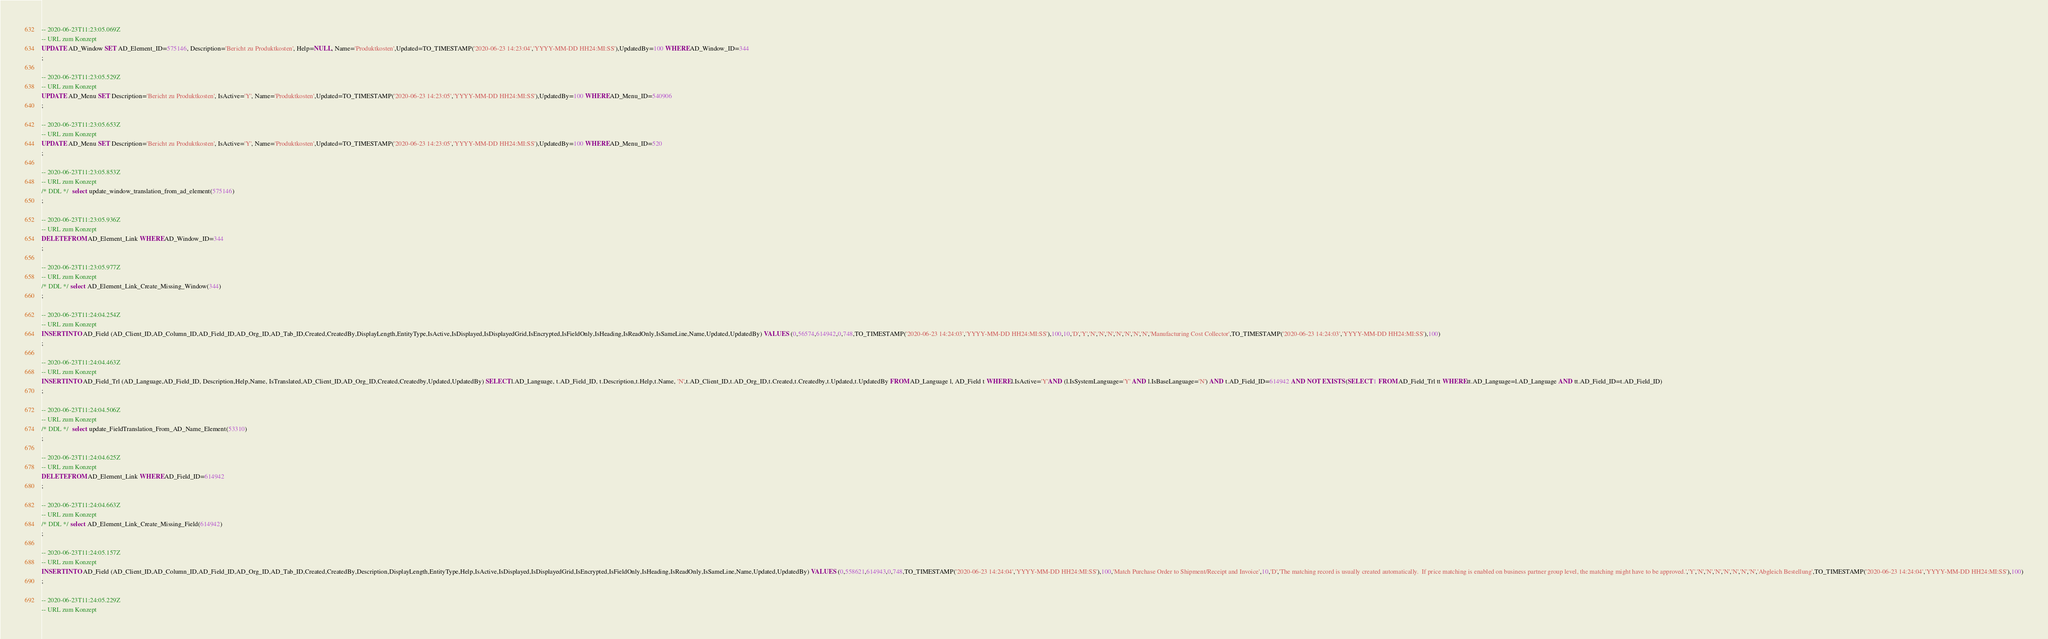Convert code to text. <code><loc_0><loc_0><loc_500><loc_500><_SQL_>-- 2020-06-23T11:23:05.069Z
-- URL zum Konzept
UPDATE AD_Window SET AD_Element_ID=575146, Description='Bericht zu Produktkosten', Help=NULL, Name='Produktkosten',Updated=TO_TIMESTAMP('2020-06-23 14:23:04','YYYY-MM-DD HH24:MI:SS'),UpdatedBy=100 WHERE AD_Window_ID=344
;

-- 2020-06-23T11:23:05.529Z
-- URL zum Konzept
UPDATE AD_Menu SET Description='Bericht zu Produktkosten', IsActive='Y', Name='Produktkosten',Updated=TO_TIMESTAMP('2020-06-23 14:23:05','YYYY-MM-DD HH24:MI:SS'),UpdatedBy=100 WHERE AD_Menu_ID=540906
;

-- 2020-06-23T11:23:05.653Z
-- URL zum Konzept
UPDATE AD_Menu SET Description='Bericht zu Produktkosten', IsActive='Y', Name='Produktkosten',Updated=TO_TIMESTAMP('2020-06-23 14:23:05','YYYY-MM-DD HH24:MI:SS'),UpdatedBy=100 WHERE AD_Menu_ID=520
;

-- 2020-06-23T11:23:05.853Z
-- URL zum Konzept
/* DDL */  select update_window_translation_from_ad_element(575146) 
;

-- 2020-06-23T11:23:05.936Z
-- URL zum Konzept
DELETE FROM AD_Element_Link WHERE AD_Window_ID=344
;

-- 2020-06-23T11:23:05.977Z
-- URL zum Konzept
/* DDL */ select AD_Element_Link_Create_Missing_Window(344)
;

-- 2020-06-23T11:24:04.254Z
-- URL zum Konzept
INSERT INTO AD_Field (AD_Client_ID,AD_Column_ID,AD_Field_ID,AD_Org_ID,AD_Tab_ID,Created,CreatedBy,DisplayLength,EntityType,IsActive,IsDisplayed,IsDisplayedGrid,IsEncrypted,IsFieldOnly,IsHeading,IsReadOnly,IsSameLine,Name,Updated,UpdatedBy) VALUES (0,56574,614942,0,748,TO_TIMESTAMP('2020-06-23 14:24:03','YYYY-MM-DD HH24:MI:SS'),100,10,'D','Y','N','N','N','N','N','N','N','Manufacturing Cost Collector',TO_TIMESTAMP('2020-06-23 14:24:03','YYYY-MM-DD HH24:MI:SS'),100)
;

-- 2020-06-23T11:24:04.463Z
-- URL zum Konzept
INSERT INTO AD_Field_Trl (AD_Language,AD_Field_ID, Description,Help,Name, IsTranslated,AD_Client_ID,AD_Org_ID,Created,Createdby,Updated,UpdatedBy) SELECT l.AD_Language, t.AD_Field_ID, t.Description,t.Help,t.Name, 'N',t.AD_Client_ID,t.AD_Org_ID,t.Created,t.Createdby,t.Updated,t.UpdatedBy FROM AD_Language l, AD_Field t WHERE l.IsActive='Y'AND (l.IsSystemLanguage='Y' AND l.IsBaseLanguage='N') AND t.AD_Field_ID=614942 AND NOT EXISTS (SELECT 1 FROM AD_Field_Trl tt WHERE tt.AD_Language=l.AD_Language AND tt.AD_Field_ID=t.AD_Field_ID)
;

-- 2020-06-23T11:24:04.506Z
-- URL zum Konzept
/* DDL */  select update_FieldTranslation_From_AD_Name_Element(53310) 
;

-- 2020-06-23T11:24:04.625Z
-- URL zum Konzept
DELETE FROM AD_Element_Link WHERE AD_Field_ID=614942
;

-- 2020-06-23T11:24:04.663Z
-- URL zum Konzept
/* DDL */ select AD_Element_Link_Create_Missing_Field(614942)
;

-- 2020-06-23T11:24:05.157Z
-- URL zum Konzept
INSERT INTO AD_Field (AD_Client_ID,AD_Column_ID,AD_Field_ID,AD_Org_ID,AD_Tab_ID,Created,CreatedBy,Description,DisplayLength,EntityType,Help,IsActive,IsDisplayed,IsDisplayedGrid,IsEncrypted,IsFieldOnly,IsHeading,IsReadOnly,IsSameLine,Name,Updated,UpdatedBy) VALUES (0,558621,614943,0,748,TO_TIMESTAMP('2020-06-23 14:24:04','YYYY-MM-DD HH24:MI:SS'),100,'Match Purchase Order to Shipment/Receipt and Invoice',10,'D','The matching record is usually created automatically.  If price matching is enabled on business partner group level, the matching might have to be approved.','Y','N','N','N','N','N','N','N','Abgleich Bestellung',TO_TIMESTAMP('2020-06-23 14:24:04','YYYY-MM-DD HH24:MI:SS'),100)
;

-- 2020-06-23T11:24:05.229Z
-- URL zum Konzept</code> 